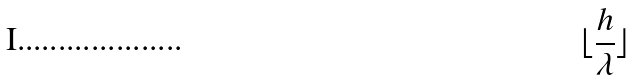Convert formula to latex. <formula><loc_0><loc_0><loc_500><loc_500>\lfloor \frac { h } { \lambda } \rfloor</formula> 